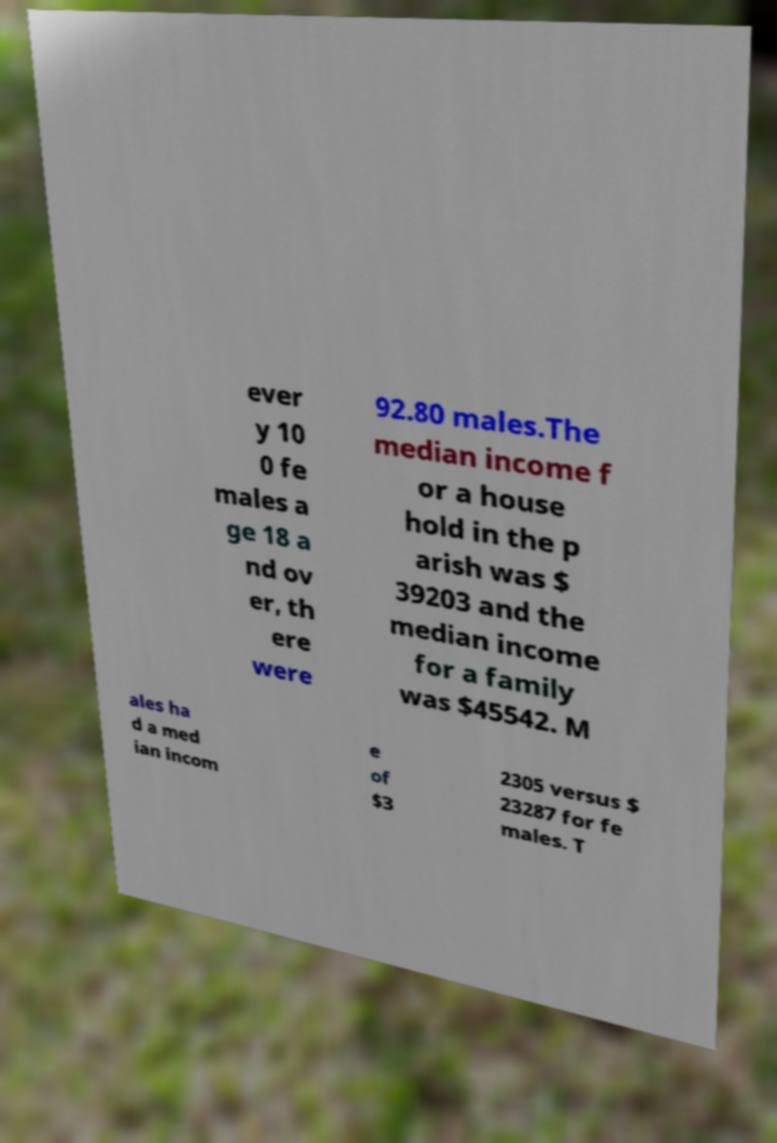Could you extract and type out the text from this image? ever y 10 0 fe males a ge 18 a nd ov er, th ere were 92.80 males.The median income f or a house hold in the p arish was $ 39203 and the median income for a family was $45542. M ales ha d a med ian incom e of $3 2305 versus $ 23287 for fe males. T 